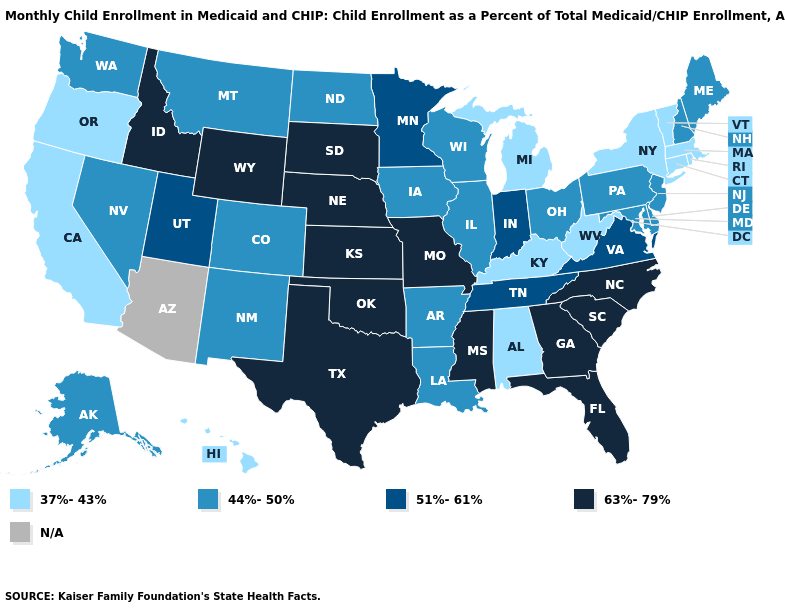Name the states that have a value in the range 63%-79%?
Answer briefly. Florida, Georgia, Idaho, Kansas, Mississippi, Missouri, Nebraska, North Carolina, Oklahoma, South Carolina, South Dakota, Texas, Wyoming. What is the highest value in states that border Oregon?
Answer briefly. 63%-79%. What is the value of Maryland?
Write a very short answer. 44%-50%. What is the value of Connecticut?
Answer briefly. 37%-43%. What is the lowest value in states that border Minnesota?
Answer briefly. 44%-50%. Among the states that border Wyoming , does Colorado have the lowest value?
Give a very brief answer. Yes. Name the states that have a value in the range 63%-79%?
Write a very short answer. Florida, Georgia, Idaho, Kansas, Mississippi, Missouri, Nebraska, North Carolina, Oklahoma, South Carolina, South Dakota, Texas, Wyoming. What is the value of Rhode Island?
Quick response, please. 37%-43%. What is the lowest value in the USA?
Quick response, please. 37%-43%. Which states have the lowest value in the Northeast?
Be succinct. Connecticut, Massachusetts, New York, Rhode Island, Vermont. What is the lowest value in the West?
Write a very short answer. 37%-43%. Does the first symbol in the legend represent the smallest category?
Give a very brief answer. Yes. Which states hav the highest value in the South?
Quick response, please. Florida, Georgia, Mississippi, North Carolina, Oklahoma, South Carolina, Texas. Is the legend a continuous bar?
Concise answer only. No. Does the first symbol in the legend represent the smallest category?
Write a very short answer. Yes. 